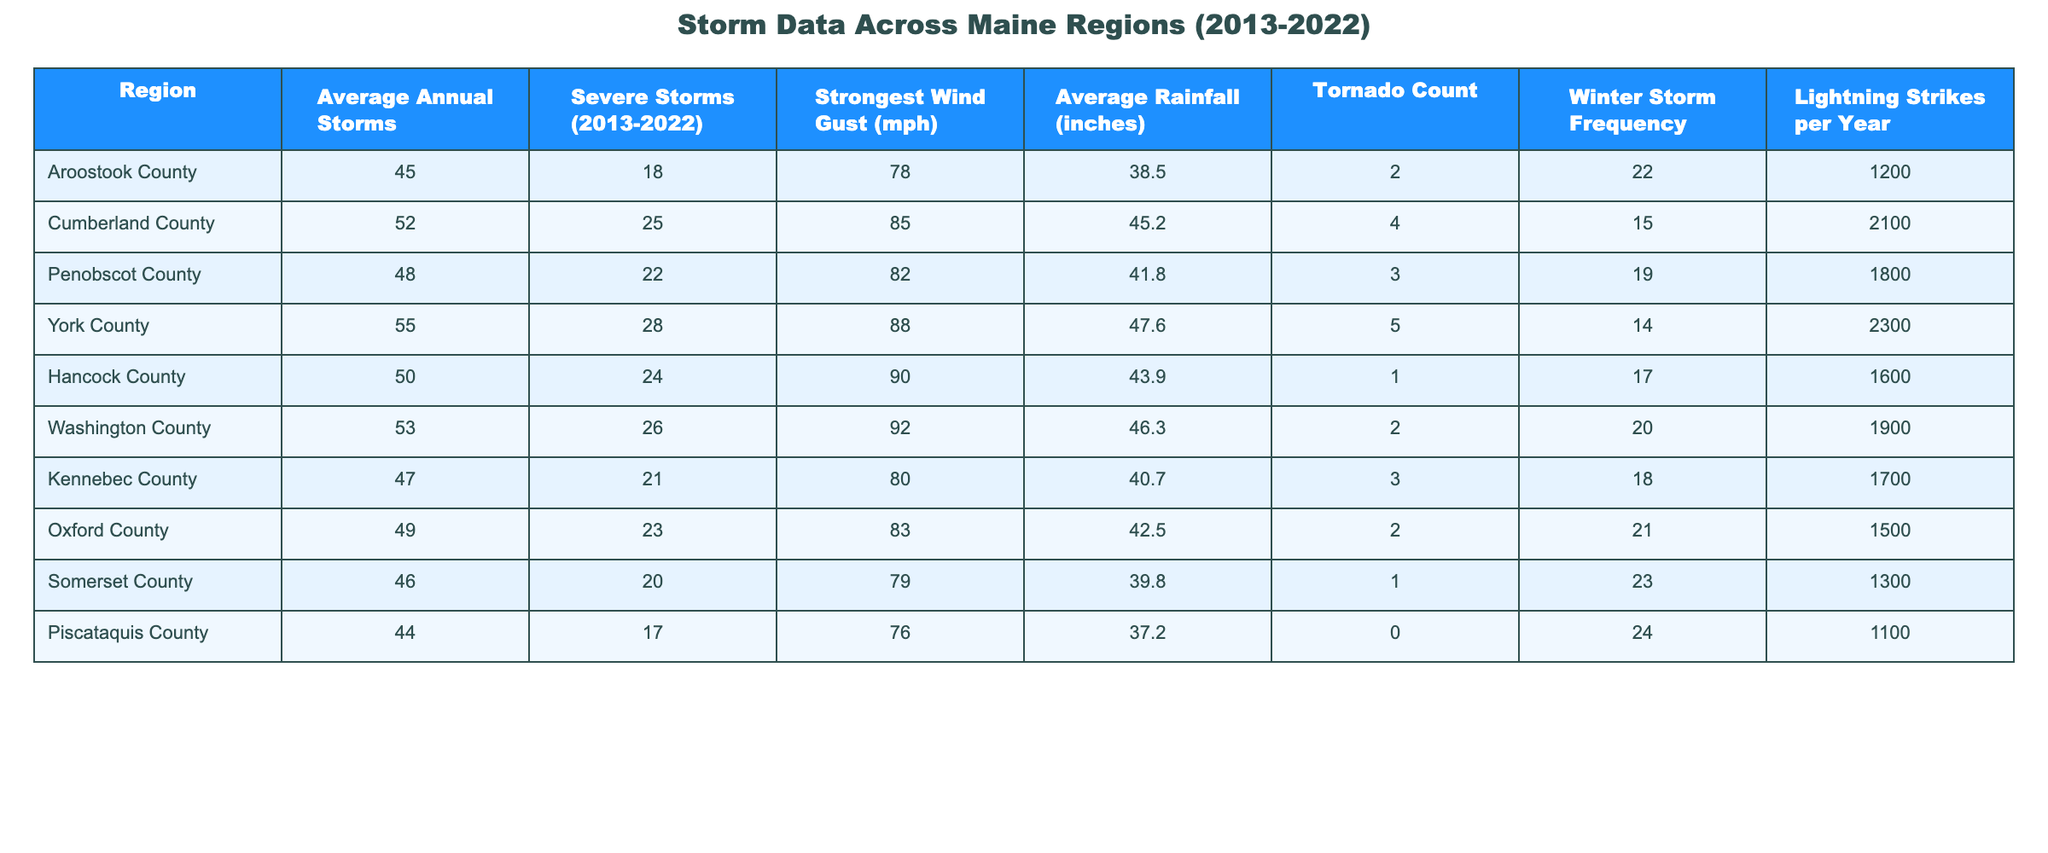What region has the highest average annual storms? The table lists the average annual storms for each region. York County has the highest average with 55 storms.
Answer: York County How many severe storms were recorded in Hancock County? Hancock County had a total of 24 severe storms during the period from 2013 to 2022.
Answer: 24 Which region has the strongest wind gust and what is its speed? The strongest wind gust recorded is in York County at 88 mph.
Answer: York County, 88 mph What is the average rainfall for Cumberland County? The average rainfall listed for Cumberland County is 45.2 inches.
Answer: 45.2 inches Is it true that Piscataquis County recorded a tornado? According to the data, Piscataquis County had a tornado count of 0, so it is false that it recorded a tornado.
Answer: False What is the difference in average annual storms between Aroostook County and Penobscot County? Aroostook County has 45 storms, while Penobscot County has 48. The difference is 48 - 45 = 3 storms.
Answer: 3 storms Which county had the lowest lightning strikes per year, and how many were there? According to the table, Piscataquis County had the lowest lightning strikes at 1100 per year.
Answer: Piscataquis County, 1100 What is the total number of severe storms across all counties? To find the total, sum the severe storms: 18 + 25 + 22 + 28 + 24 + 26 + 21 + 23 + 20 + 17 =  224.
Answer: 224 How many regions had a tornado count of at least 3? By reviewing the tornado counts, only Kennebec County and Cumberland County had counts of 3 or more (4 and 3 respectively). This totals 5 regions (Kennebec, Cumberland, Penobscot, York, and Aroostook).
Answer: 5 regions What is the average number of severe storms across all counties? To find the average, total the severe storms (224) and divide by the number of regions (10): 224 / 10 = 22.4.
Answer: 22.4 